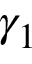Convert formula to latex. <formula><loc_0><loc_0><loc_500><loc_500>\gamma _ { 1 }</formula> 